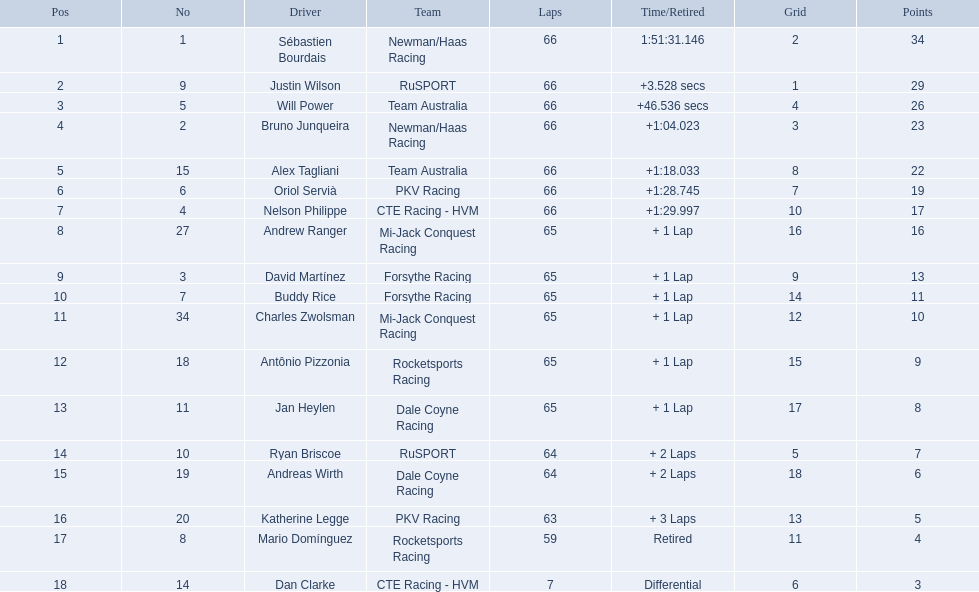Who are the chauffeurs? Sébastien Bourdais, Justin Wilson, Will Power, Bruno Junqueira, Alex Tagliani, Oriol Servià, Nelson Philippe, Andrew Ranger, David Martínez, Buddy Rice, Charles Zwolsman, Antônio Pizzonia, Jan Heylen, Ryan Briscoe, Andreas Wirth, Katherine Legge, Mario Domínguez, Dan Clarke. What are their numerals? 1, 9, 5, 2, 15, 6, 4, 27, 3, 7, 34, 18, 11, 10, 19, 20, 8, 14. What are their spots? 1, 2, 3, 4, 5, 6, 7, 8, 9, 10, 11, 12, 13, 14, 15, 16, 17, 18. Which chauffeur has the same numeral and spot? Sébastien Bourdais. How many points were awarded to the person in first place? 34. How many points did the person in last place get? 3. Who was the one with the lowest points? Dan Clarke. 